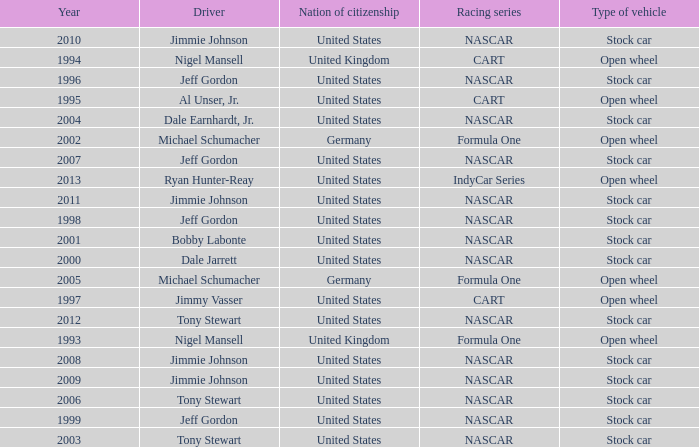What Nation of citizenship has a stock car vehicle with a year of 1999? United States. Give me the full table as a dictionary. {'header': ['Year', 'Driver', 'Nation of citizenship', 'Racing series', 'Type of vehicle'], 'rows': [['2010', 'Jimmie Johnson', 'United States', 'NASCAR', 'Stock car'], ['1994', 'Nigel Mansell', 'United Kingdom', 'CART', 'Open wheel'], ['1996', 'Jeff Gordon', 'United States', 'NASCAR', 'Stock car'], ['1995', 'Al Unser, Jr.', 'United States', 'CART', 'Open wheel'], ['2004', 'Dale Earnhardt, Jr.', 'United States', 'NASCAR', 'Stock car'], ['2002', 'Michael Schumacher', 'Germany', 'Formula One', 'Open wheel'], ['2007', 'Jeff Gordon', 'United States', 'NASCAR', 'Stock car'], ['2013', 'Ryan Hunter-Reay', 'United States', 'IndyCar Series', 'Open wheel'], ['2011', 'Jimmie Johnson', 'United States', 'NASCAR', 'Stock car'], ['1998', 'Jeff Gordon', 'United States', 'NASCAR', 'Stock car'], ['2001', 'Bobby Labonte', 'United States', 'NASCAR', 'Stock car'], ['2000', 'Dale Jarrett', 'United States', 'NASCAR', 'Stock car'], ['2005', 'Michael Schumacher', 'Germany', 'Formula One', 'Open wheel'], ['1997', 'Jimmy Vasser', 'United States', 'CART', 'Open wheel'], ['2012', 'Tony Stewart', 'United States', 'NASCAR', 'Stock car'], ['1993', 'Nigel Mansell', 'United Kingdom', 'Formula One', 'Open wheel'], ['2008', 'Jimmie Johnson', 'United States', 'NASCAR', 'Stock car'], ['2009', 'Jimmie Johnson', 'United States', 'NASCAR', 'Stock car'], ['2006', 'Tony Stewart', 'United States', 'NASCAR', 'Stock car'], ['1999', 'Jeff Gordon', 'United States', 'NASCAR', 'Stock car'], ['2003', 'Tony Stewart', 'United States', 'NASCAR', 'Stock car']]} 